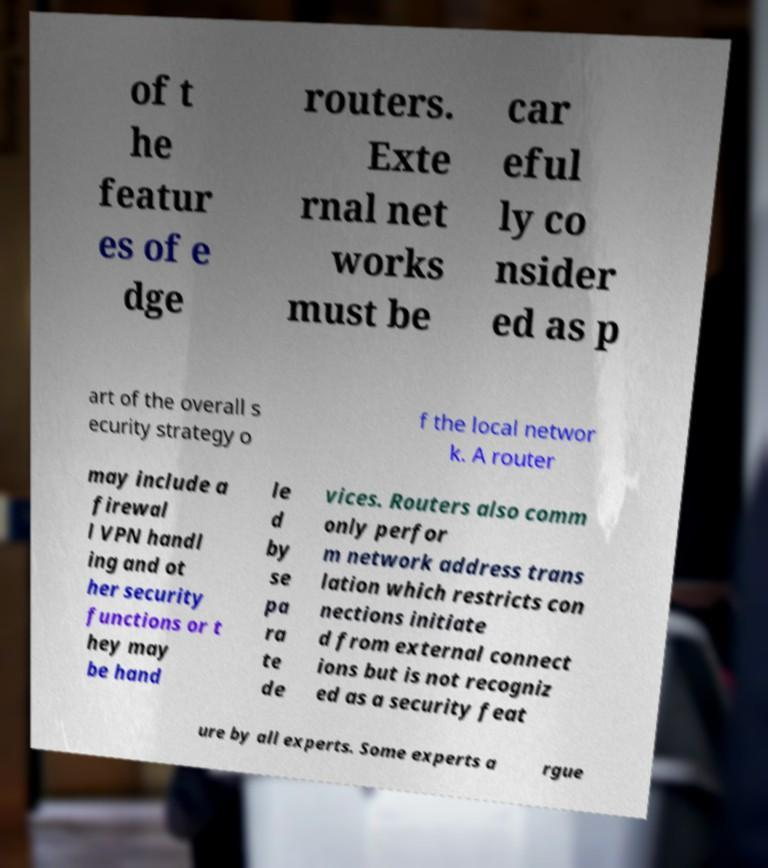For documentation purposes, I need the text within this image transcribed. Could you provide that? of t he featur es of e dge routers. Exte rnal net works must be car eful ly co nsider ed as p art of the overall s ecurity strategy o f the local networ k. A router may include a firewal l VPN handl ing and ot her security functions or t hey may be hand le d by se pa ra te de vices. Routers also comm only perfor m network address trans lation which restricts con nections initiate d from external connect ions but is not recogniz ed as a security feat ure by all experts. Some experts a rgue 